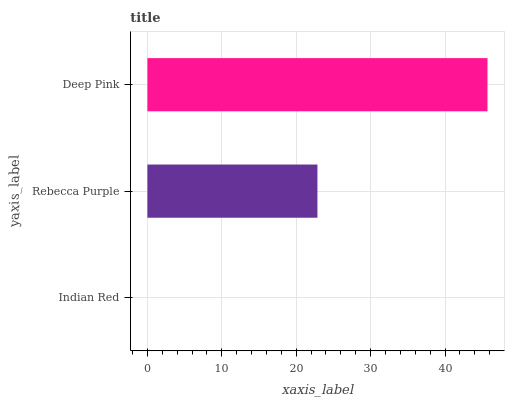Is Indian Red the minimum?
Answer yes or no. Yes. Is Deep Pink the maximum?
Answer yes or no. Yes. Is Rebecca Purple the minimum?
Answer yes or no. No. Is Rebecca Purple the maximum?
Answer yes or no. No. Is Rebecca Purple greater than Indian Red?
Answer yes or no. Yes. Is Indian Red less than Rebecca Purple?
Answer yes or no. Yes. Is Indian Red greater than Rebecca Purple?
Answer yes or no. No. Is Rebecca Purple less than Indian Red?
Answer yes or no. No. Is Rebecca Purple the high median?
Answer yes or no. Yes. Is Rebecca Purple the low median?
Answer yes or no. Yes. Is Indian Red the high median?
Answer yes or no. No. Is Indian Red the low median?
Answer yes or no. No. 